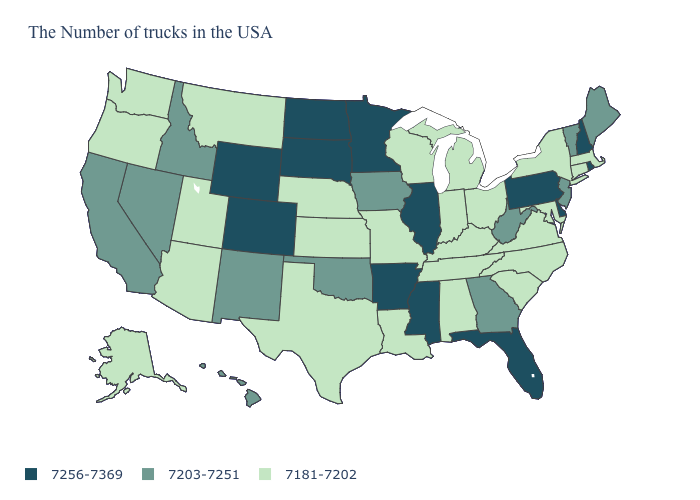Does Mississippi have the same value as Wyoming?
Quick response, please. Yes. Does Hawaii have the lowest value in the West?
Quick response, please. No. What is the value of Hawaii?
Quick response, please. 7203-7251. Does Virginia have the same value as Washington?
Short answer required. Yes. Among the states that border New Jersey , does New York have the highest value?
Answer briefly. No. What is the value of Mississippi?
Short answer required. 7256-7369. What is the lowest value in the Northeast?
Quick response, please. 7181-7202. What is the value of Maine?
Short answer required. 7203-7251. Does Massachusetts have a higher value than Wyoming?
Write a very short answer. No. What is the value of West Virginia?
Keep it brief. 7203-7251. Name the states that have a value in the range 7181-7202?
Short answer required. Massachusetts, Connecticut, New York, Maryland, Virginia, North Carolina, South Carolina, Ohio, Michigan, Kentucky, Indiana, Alabama, Tennessee, Wisconsin, Louisiana, Missouri, Kansas, Nebraska, Texas, Utah, Montana, Arizona, Washington, Oregon, Alaska. What is the value of Mississippi?
Answer briefly. 7256-7369. Name the states that have a value in the range 7256-7369?
Be succinct. Rhode Island, New Hampshire, Delaware, Pennsylvania, Florida, Illinois, Mississippi, Arkansas, Minnesota, South Dakota, North Dakota, Wyoming, Colorado. How many symbols are there in the legend?
Keep it brief. 3. Name the states that have a value in the range 7181-7202?
Quick response, please. Massachusetts, Connecticut, New York, Maryland, Virginia, North Carolina, South Carolina, Ohio, Michigan, Kentucky, Indiana, Alabama, Tennessee, Wisconsin, Louisiana, Missouri, Kansas, Nebraska, Texas, Utah, Montana, Arizona, Washington, Oregon, Alaska. 